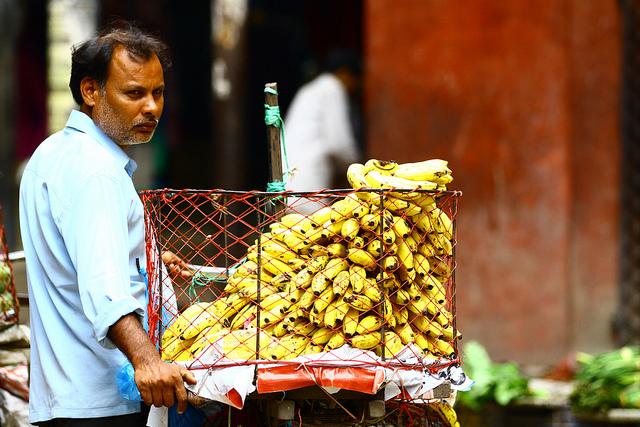What is the man doing with all these bananas?
Give a very brief answer. Selling. Is this person wearing gloves?
Keep it brief. No. How many different fruits are there?
Short answer required. 1. What type of fruit is the main subject?
Concise answer only. Bananas. 